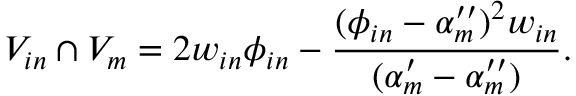<formula> <loc_0><loc_0><loc_500><loc_500>V _ { i n } \cap V _ { m } = 2 w _ { i n } \phi _ { i n } - \frac { ( \phi _ { i n } - \alpha _ { m } ^ { \prime \prime } ) ^ { 2 } w _ { i n } } { ( \alpha _ { m } ^ { \prime } - \alpha _ { m } ^ { \prime \prime } ) } .</formula> 